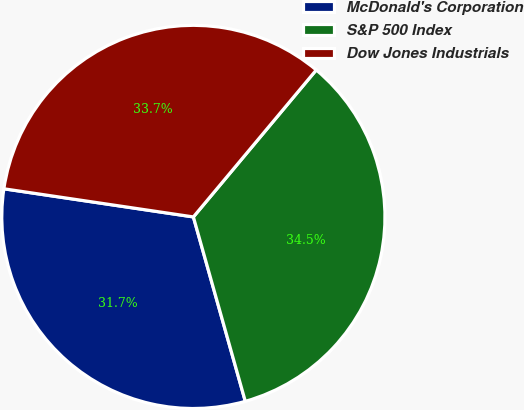<chart> <loc_0><loc_0><loc_500><loc_500><pie_chart><fcel>McDonald's Corporation<fcel>S&P 500 Index<fcel>Dow Jones Industrials<nl><fcel>31.72%<fcel>34.55%<fcel>33.74%<nl></chart> 